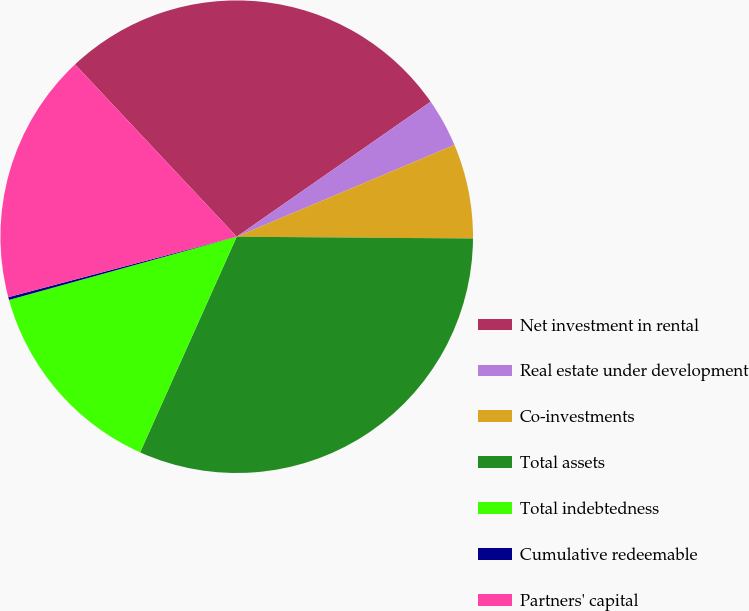Convert chart. <chart><loc_0><loc_0><loc_500><loc_500><pie_chart><fcel>Net investment in rental<fcel>Real estate under development<fcel>Co-investments<fcel>Total assets<fcel>Total indebtedness<fcel>Cumulative redeemable<fcel>Partners' capital<nl><fcel>27.32%<fcel>3.33%<fcel>6.47%<fcel>31.59%<fcel>13.99%<fcel>0.19%<fcel>17.13%<nl></chart> 